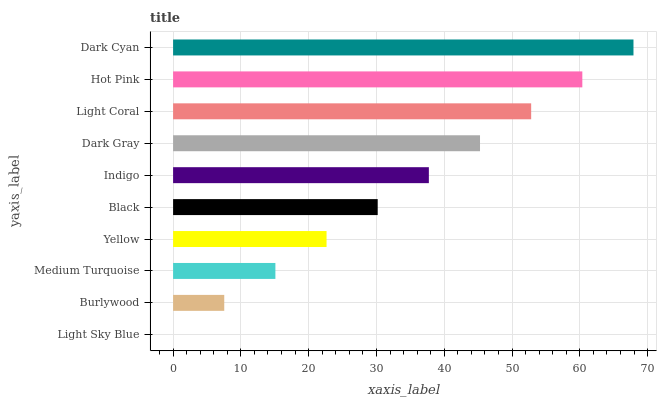Is Light Sky Blue the minimum?
Answer yes or no. Yes. Is Dark Cyan the maximum?
Answer yes or no. Yes. Is Burlywood the minimum?
Answer yes or no. No. Is Burlywood the maximum?
Answer yes or no. No. Is Burlywood greater than Light Sky Blue?
Answer yes or no. Yes. Is Light Sky Blue less than Burlywood?
Answer yes or no. Yes. Is Light Sky Blue greater than Burlywood?
Answer yes or no. No. Is Burlywood less than Light Sky Blue?
Answer yes or no. No. Is Indigo the high median?
Answer yes or no. Yes. Is Black the low median?
Answer yes or no. Yes. Is Medium Turquoise the high median?
Answer yes or no. No. Is Indigo the low median?
Answer yes or no. No. 